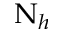<formula> <loc_0><loc_0><loc_500><loc_500>\nu _ { h }</formula> 